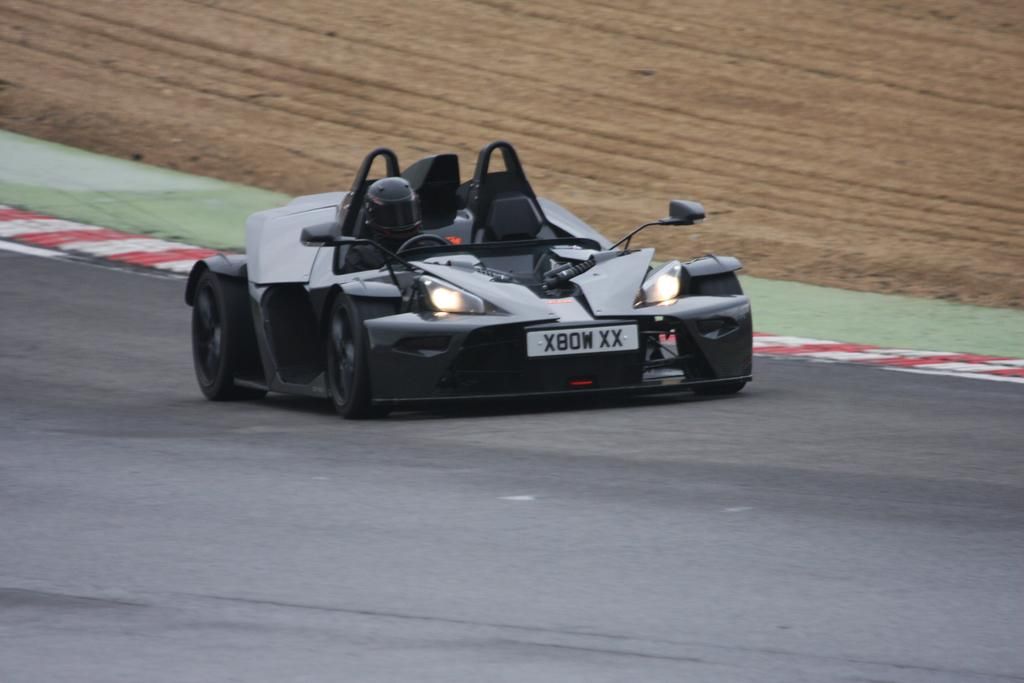What type of vehicle is on the road in the image? There is a race car on the road in the image. What is the condition of the road beside the race car? There is a mud road beside the race car. Can you tell me how many dinosaurs are running alongside the race car in the image? There are no dinosaurs present in the image; it features a race car on a road with a mud road beside it. 